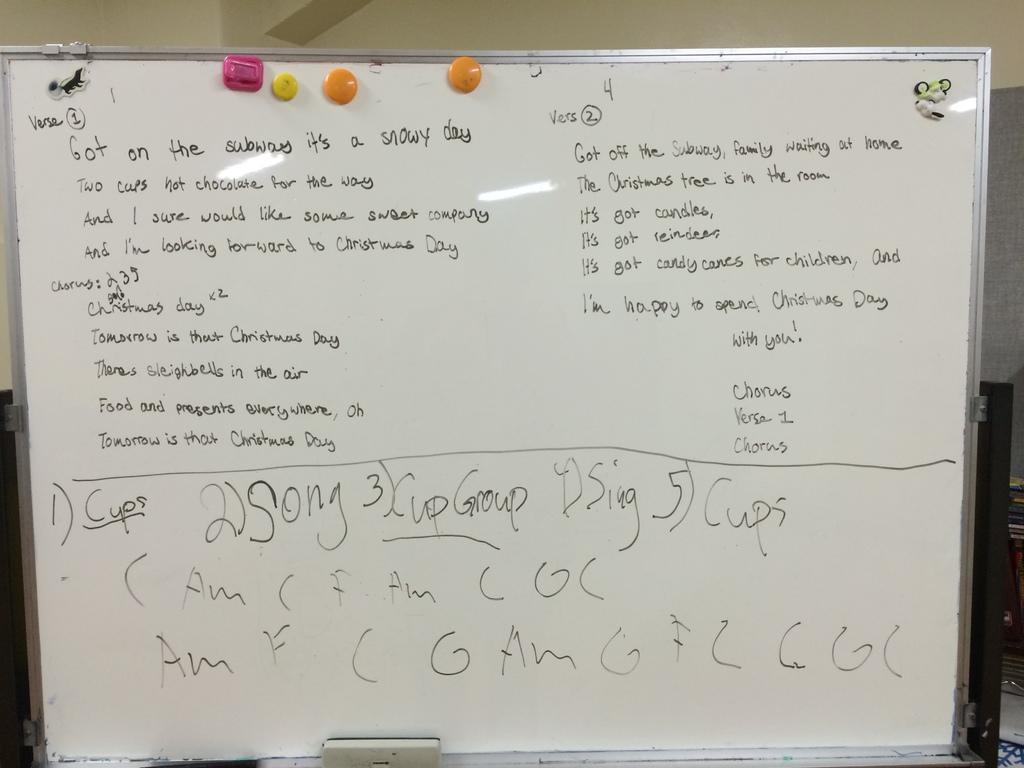<image>
Describe the image concisely. A whiteboard has the word "cups" underlined in black text. 